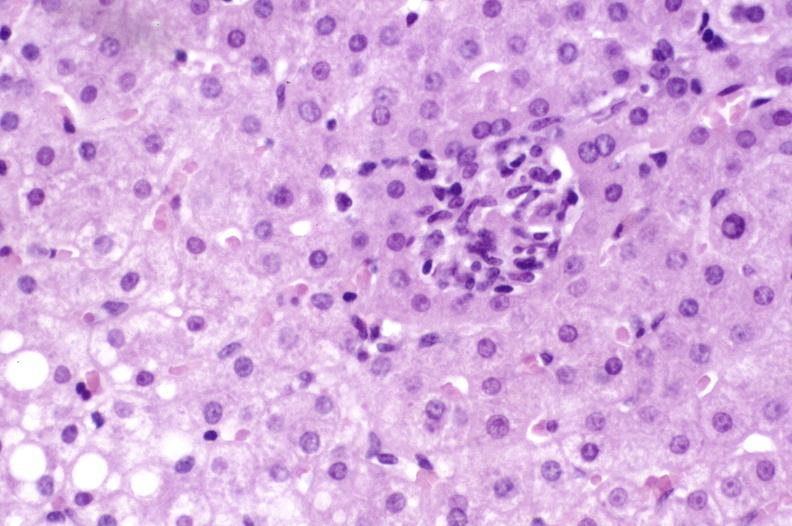what is present?
Answer the question using a single word or phrase. Liver 